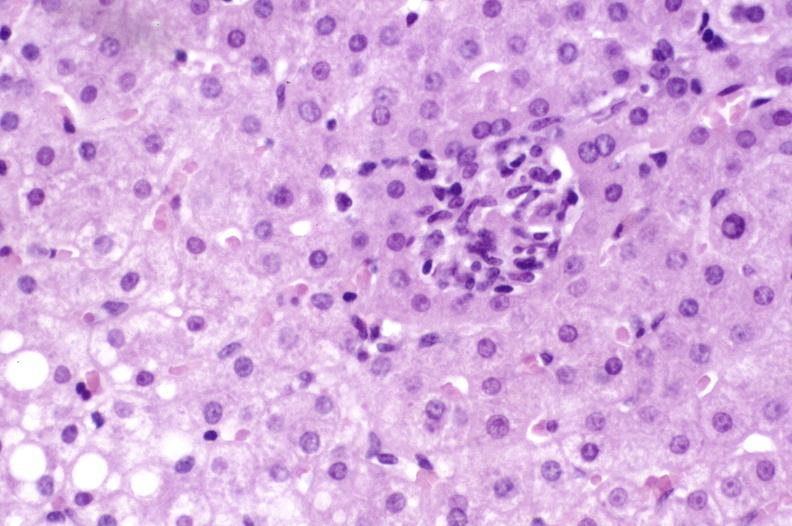what is present?
Answer the question using a single word or phrase. Liver 